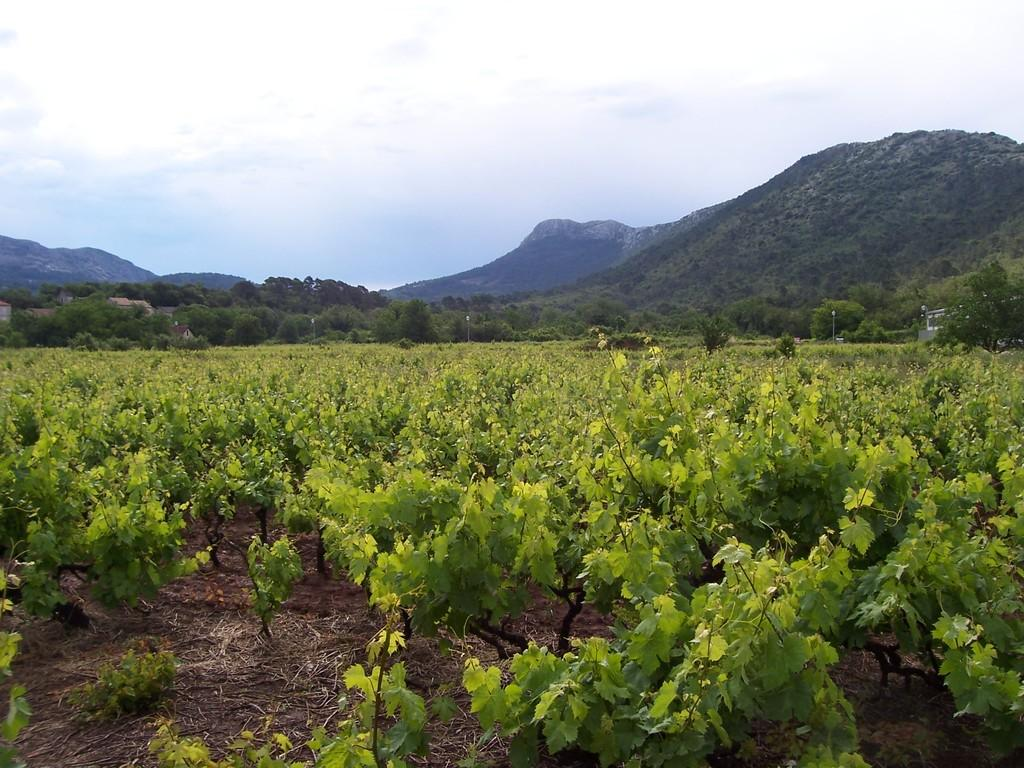What type of vegetation can be seen in the image? There are plants and trees in the image. What type of landscape feature is present in the image? There are hills in the image. What can be seen in the sky in the image? Clouds are visible in the image. What type of drum can be seen in the image? There is no drum present in the image. How is the quilt used in the image? There is no quilt present in the image. 